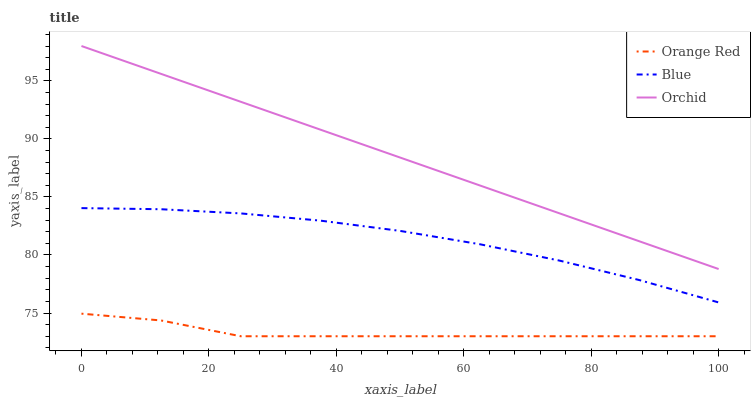Does Orange Red have the minimum area under the curve?
Answer yes or no. Yes. Does Orchid have the maximum area under the curve?
Answer yes or no. Yes. Does Orchid have the minimum area under the curve?
Answer yes or no. No. Does Orange Red have the maximum area under the curve?
Answer yes or no. No. Is Orchid the smoothest?
Answer yes or no. Yes. Is Orange Red the roughest?
Answer yes or no. Yes. Is Orange Red the smoothest?
Answer yes or no. No. Is Orchid the roughest?
Answer yes or no. No. Does Orange Red have the lowest value?
Answer yes or no. Yes. Does Orchid have the lowest value?
Answer yes or no. No. Does Orchid have the highest value?
Answer yes or no. Yes. Does Orange Red have the highest value?
Answer yes or no. No. Is Blue less than Orchid?
Answer yes or no. Yes. Is Blue greater than Orange Red?
Answer yes or no. Yes. Does Blue intersect Orchid?
Answer yes or no. No. 